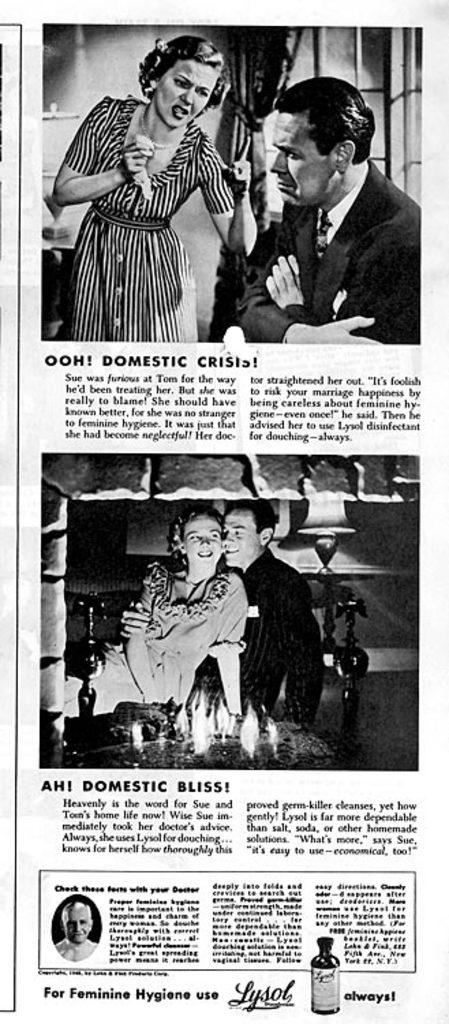What is present in the image that contains both text and images? There is a poster in the image that contains text and images. Who is the owner of the button in the image? There is no button present in the image, so there is no owner to consider. 